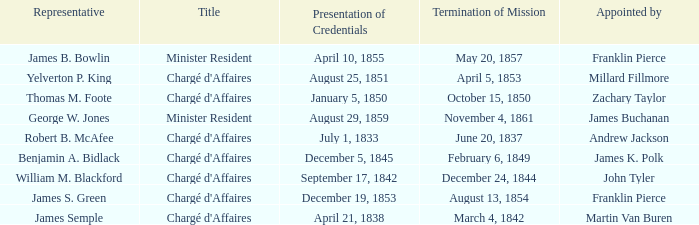What Title has a Termination of Mission for August 13, 1854? Chargé d'Affaires. 